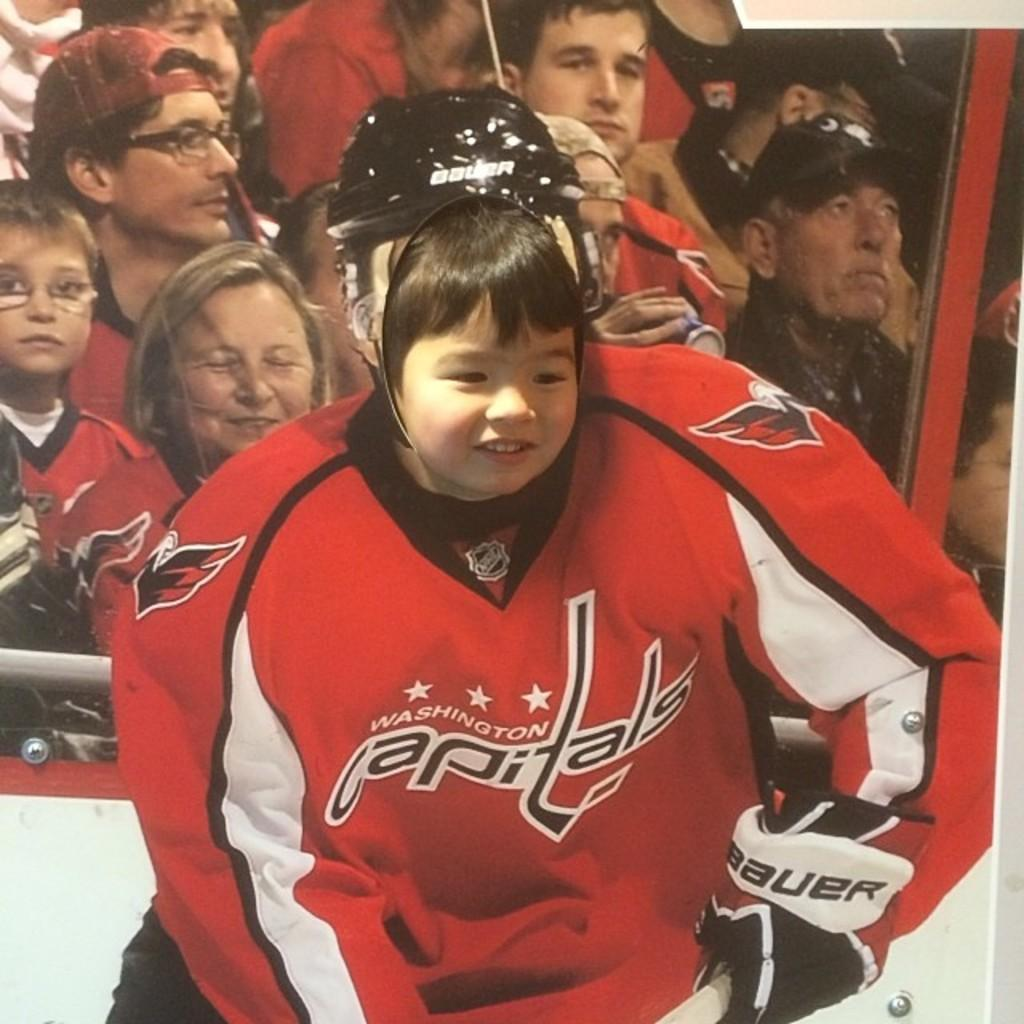<image>
Provide a brief description of the given image. Baby's face on a hockey player with a jersey that says Capitals. 